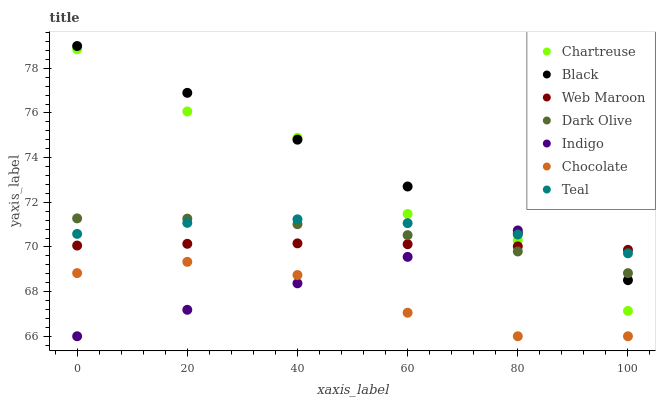Does Chocolate have the minimum area under the curve?
Answer yes or no. Yes. Does Black have the maximum area under the curve?
Answer yes or no. Yes. Does Dark Olive have the minimum area under the curve?
Answer yes or no. No. Does Dark Olive have the maximum area under the curve?
Answer yes or no. No. Is Black the smoothest?
Answer yes or no. Yes. Is Chartreuse the roughest?
Answer yes or no. Yes. Is Dark Olive the smoothest?
Answer yes or no. No. Is Dark Olive the roughest?
Answer yes or no. No. Does Indigo have the lowest value?
Answer yes or no. Yes. Does Dark Olive have the lowest value?
Answer yes or no. No. Does Black have the highest value?
Answer yes or no. Yes. Does Dark Olive have the highest value?
Answer yes or no. No. Is Chocolate less than Dark Olive?
Answer yes or no. Yes. Is Chartreuse greater than Chocolate?
Answer yes or no. Yes. Does Chartreuse intersect Teal?
Answer yes or no. Yes. Is Chartreuse less than Teal?
Answer yes or no. No. Is Chartreuse greater than Teal?
Answer yes or no. No. Does Chocolate intersect Dark Olive?
Answer yes or no. No. 